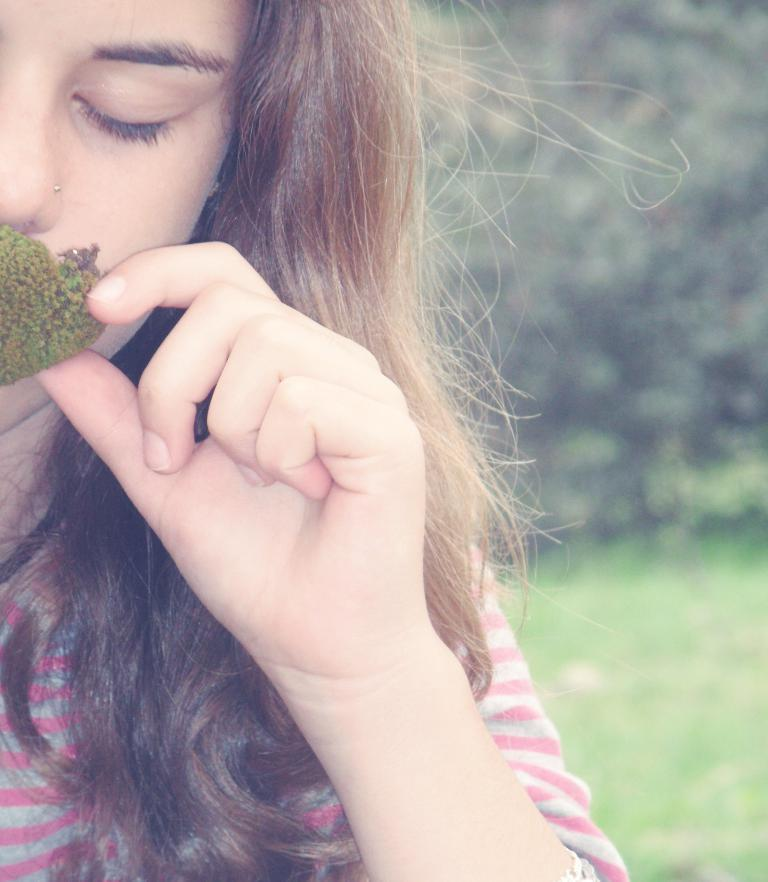Who is the main subject in the image? There is a woman in the image. What is the woman holding in her hand? The woman is holding a bud in her hand. What type of vegetation can be seen in the image? There are trees visible in the image. What is the ground made of in the image? There is grass on the ground in the image. How many children are playing with the lamp on the island in the image? There are no children, lamp, or island present in the image. 